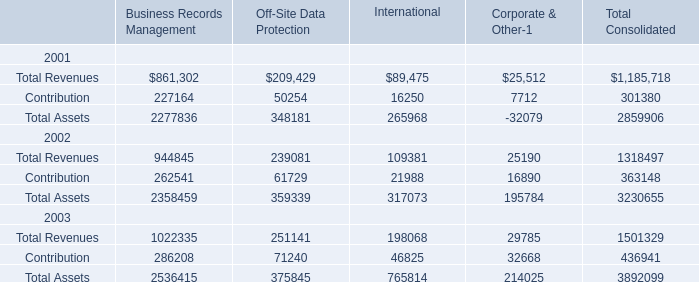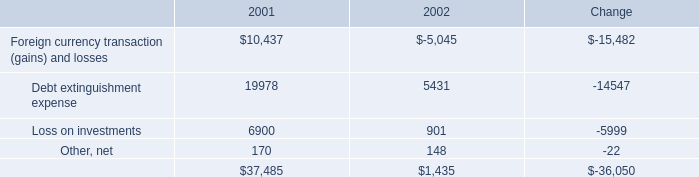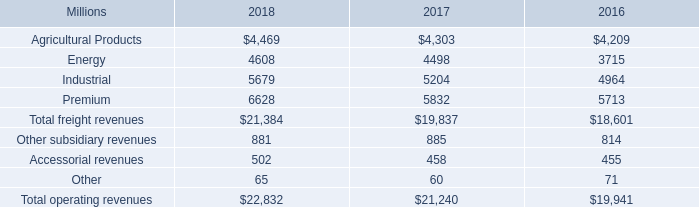What is the percentage of all International that are positive to the total amount, in 2002? 
Computations: (((109381 + 21988) + 317073) / ((109381 + 21988) + 317073))
Answer: 1.0. assuming the same rate of growth as in 2018 , what would industrial segment revenues grow to in 2019? 
Computations: ((5679 / 5204) * 5679)
Answer: 6197.35607. What was the average value of Total Revenues, Contribution,Total Assets in 2001 for Business Records Management? 
Computations: (((861302 + 227164) + 2277836) / 3)
Answer: 1122100.66667. 